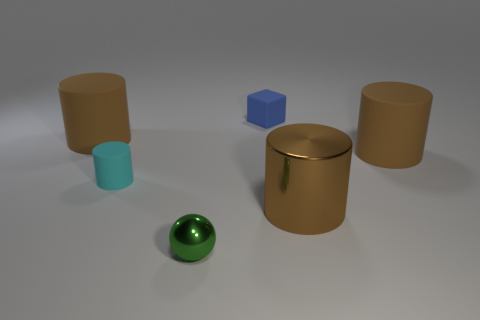Subtract all yellow balls. How many brown cylinders are left? 3 Subtract 1 cylinders. How many cylinders are left? 3 Add 4 cyan rubber cylinders. How many objects exist? 10 Subtract all cubes. How many objects are left? 5 Add 6 large cylinders. How many large cylinders exist? 9 Subtract 0 yellow blocks. How many objects are left? 6 Subtract all green metal balls. Subtract all green balls. How many objects are left? 4 Add 4 small cyan things. How many small cyan things are left? 5 